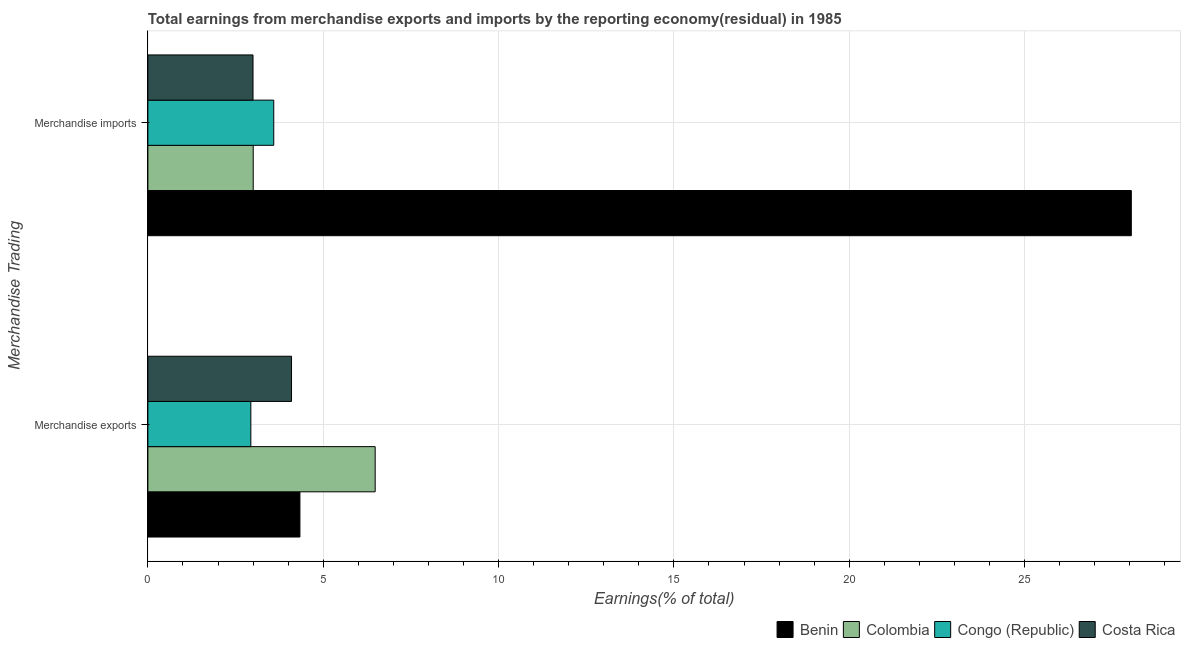Are the number of bars per tick equal to the number of legend labels?
Make the answer very short. Yes. How many bars are there on the 2nd tick from the top?
Ensure brevity in your answer.  4. What is the earnings from merchandise exports in Costa Rica?
Make the answer very short. 4.1. Across all countries, what is the maximum earnings from merchandise exports?
Give a very brief answer. 6.48. Across all countries, what is the minimum earnings from merchandise imports?
Your answer should be very brief. 3. In which country was the earnings from merchandise imports maximum?
Offer a terse response. Benin. What is the total earnings from merchandise exports in the graph?
Provide a short and direct response. 17.85. What is the difference between the earnings from merchandise imports in Congo (Republic) and that in Colombia?
Your answer should be compact. 0.59. What is the difference between the earnings from merchandise exports in Colombia and the earnings from merchandise imports in Costa Rica?
Make the answer very short. 3.48. What is the average earnings from merchandise exports per country?
Provide a succinct answer. 4.46. What is the difference between the earnings from merchandise imports and earnings from merchandise exports in Congo (Republic)?
Offer a terse response. 0.65. In how many countries, is the earnings from merchandise imports greater than 22 %?
Your answer should be very brief. 1. What is the ratio of the earnings from merchandise exports in Colombia to that in Congo (Republic)?
Your response must be concise. 2.21. Is the earnings from merchandise imports in Colombia less than that in Congo (Republic)?
Give a very brief answer. Yes. What does the 4th bar from the top in Merchandise imports represents?
Give a very brief answer. Benin. What does the 1st bar from the bottom in Merchandise exports represents?
Your response must be concise. Benin. Are the values on the major ticks of X-axis written in scientific E-notation?
Make the answer very short. No. Does the graph contain grids?
Give a very brief answer. Yes. Where does the legend appear in the graph?
Ensure brevity in your answer.  Bottom right. How are the legend labels stacked?
Ensure brevity in your answer.  Horizontal. What is the title of the graph?
Provide a short and direct response. Total earnings from merchandise exports and imports by the reporting economy(residual) in 1985. What is the label or title of the X-axis?
Provide a short and direct response. Earnings(% of total). What is the label or title of the Y-axis?
Your answer should be very brief. Merchandise Trading. What is the Earnings(% of total) of Benin in Merchandise exports?
Your answer should be compact. 4.34. What is the Earnings(% of total) in Colombia in Merchandise exports?
Give a very brief answer. 6.48. What is the Earnings(% of total) of Congo (Republic) in Merchandise exports?
Make the answer very short. 2.94. What is the Earnings(% of total) in Costa Rica in Merchandise exports?
Offer a terse response. 4.1. What is the Earnings(% of total) of Benin in Merchandise imports?
Keep it short and to the point. 28.04. What is the Earnings(% of total) of Colombia in Merchandise imports?
Make the answer very short. 3. What is the Earnings(% of total) in Congo (Republic) in Merchandise imports?
Ensure brevity in your answer.  3.59. What is the Earnings(% of total) in Costa Rica in Merchandise imports?
Ensure brevity in your answer.  3. Across all Merchandise Trading, what is the maximum Earnings(% of total) in Benin?
Keep it short and to the point. 28.04. Across all Merchandise Trading, what is the maximum Earnings(% of total) of Colombia?
Give a very brief answer. 6.48. Across all Merchandise Trading, what is the maximum Earnings(% of total) in Congo (Republic)?
Keep it short and to the point. 3.59. Across all Merchandise Trading, what is the maximum Earnings(% of total) of Costa Rica?
Your response must be concise. 4.1. Across all Merchandise Trading, what is the minimum Earnings(% of total) in Benin?
Keep it short and to the point. 4.34. Across all Merchandise Trading, what is the minimum Earnings(% of total) in Colombia?
Provide a succinct answer. 3. Across all Merchandise Trading, what is the minimum Earnings(% of total) in Congo (Republic)?
Provide a succinct answer. 2.94. Across all Merchandise Trading, what is the minimum Earnings(% of total) of Costa Rica?
Offer a very short reply. 3. What is the total Earnings(% of total) of Benin in the graph?
Your response must be concise. 32.38. What is the total Earnings(% of total) of Colombia in the graph?
Ensure brevity in your answer.  9.49. What is the total Earnings(% of total) of Congo (Republic) in the graph?
Offer a very short reply. 6.53. What is the total Earnings(% of total) of Costa Rica in the graph?
Keep it short and to the point. 7.09. What is the difference between the Earnings(% of total) in Benin in Merchandise exports and that in Merchandise imports?
Provide a succinct answer. -23.71. What is the difference between the Earnings(% of total) of Colombia in Merchandise exports and that in Merchandise imports?
Give a very brief answer. 3.48. What is the difference between the Earnings(% of total) in Congo (Republic) in Merchandise exports and that in Merchandise imports?
Give a very brief answer. -0.65. What is the difference between the Earnings(% of total) of Costa Rica in Merchandise exports and that in Merchandise imports?
Provide a succinct answer. 1.1. What is the difference between the Earnings(% of total) of Benin in Merchandise exports and the Earnings(% of total) of Colombia in Merchandise imports?
Keep it short and to the point. 1.33. What is the difference between the Earnings(% of total) of Benin in Merchandise exports and the Earnings(% of total) of Congo (Republic) in Merchandise imports?
Your answer should be compact. 0.75. What is the difference between the Earnings(% of total) of Benin in Merchandise exports and the Earnings(% of total) of Costa Rica in Merchandise imports?
Provide a succinct answer. 1.34. What is the difference between the Earnings(% of total) of Colombia in Merchandise exports and the Earnings(% of total) of Congo (Republic) in Merchandise imports?
Ensure brevity in your answer.  2.89. What is the difference between the Earnings(% of total) of Colombia in Merchandise exports and the Earnings(% of total) of Costa Rica in Merchandise imports?
Ensure brevity in your answer.  3.48. What is the difference between the Earnings(% of total) in Congo (Republic) in Merchandise exports and the Earnings(% of total) in Costa Rica in Merchandise imports?
Offer a terse response. -0.06. What is the average Earnings(% of total) in Benin per Merchandise Trading?
Your answer should be very brief. 16.19. What is the average Earnings(% of total) in Colombia per Merchandise Trading?
Make the answer very short. 4.74. What is the average Earnings(% of total) of Congo (Republic) per Merchandise Trading?
Make the answer very short. 3.26. What is the average Earnings(% of total) in Costa Rica per Merchandise Trading?
Offer a very short reply. 3.55. What is the difference between the Earnings(% of total) of Benin and Earnings(% of total) of Colombia in Merchandise exports?
Provide a short and direct response. -2.15. What is the difference between the Earnings(% of total) of Benin and Earnings(% of total) of Congo (Republic) in Merchandise exports?
Ensure brevity in your answer.  1.4. What is the difference between the Earnings(% of total) of Benin and Earnings(% of total) of Costa Rica in Merchandise exports?
Your answer should be compact. 0.24. What is the difference between the Earnings(% of total) in Colombia and Earnings(% of total) in Congo (Republic) in Merchandise exports?
Your answer should be compact. 3.55. What is the difference between the Earnings(% of total) in Colombia and Earnings(% of total) in Costa Rica in Merchandise exports?
Your response must be concise. 2.39. What is the difference between the Earnings(% of total) in Congo (Republic) and Earnings(% of total) in Costa Rica in Merchandise exports?
Make the answer very short. -1.16. What is the difference between the Earnings(% of total) in Benin and Earnings(% of total) in Colombia in Merchandise imports?
Provide a succinct answer. 25.04. What is the difference between the Earnings(% of total) in Benin and Earnings(% of total) in Congo (Republic) in Merchandise imports?
Ensure brevity in your answer.  24.45. What is the difference between the Earnings(% of total) of Benin and Earnings(% of total) of Costa Rica in Merchandise imports?
Ensure brevity in your answer.  25.05. What is the difference between the Earnings(% of total) of Colombia and Earnings(% of total) of Congo (Republic) in Merchandise imports?
Your response must be concise. -0.59. What is the difference between the Earnings(% of total) in Colombia and Earnings(% of total) in Costa Rica in Merchandise imports?
Give a very brief answer. 0.01. What is the difference between the Earnings(% of total) of Congo (Republic) and Earnings(% of total) of Costa Rica in Merchandise imports?
Give a very brief answer. 0.59. What is the ratio of the Earnings(% of total) in Benin in Merchandise exports to that in Merchandise imports?
Your answer should be compact. 0.15. What is the ratio of the Earnings(% of total) of Colombia in Merchandise exports to that in Merchandise imports?
Your response must be concise. 2.16. What is the ratio of the Earnings(% of total) of Congo (Republic) in Merchandise exports to that in Merchandise imports?
Give a very brief answer. 0.82. What is the ratio of the Earnings(% of total) of Costa Rica in Merchandise exports to that in Merchandise imports?
Ensure brevity in your answer.  1.37. What is the difference between the highest and the second highest Earnings(% of total) of Benin?
Keep it short and to the point. 23.71. What is the difference between the highest and the second highest Earnings(% of total) of Colombia?
Keep it short and to the point. 3.48. What is the difference between the highest and the second highest Earnings(% of total) of Congo (Republic)?
Keep it short and to the point. 0.65. What is the difference between the highest and the second highest Earnings(% of total) in Costa Rica?
Provide a succinct answer. 1.1. What is the difference between the highest and the lowest Earnings(% of total) of Benin?
Make the answer very short. 23.71. What is the difference between the highest and the lowest Earnings(% of total) of Colombia?
Provide a succinct answer. 3.48. What is the difference between the highest and the lowest Earnings(% of total) in Congo (Republic)?
Offer a terse response. 0.65. What is the difference between the highest and the lowest Earnings(% of total) in Costa Rica?
Ensure brevity in your answer.  1.1. 